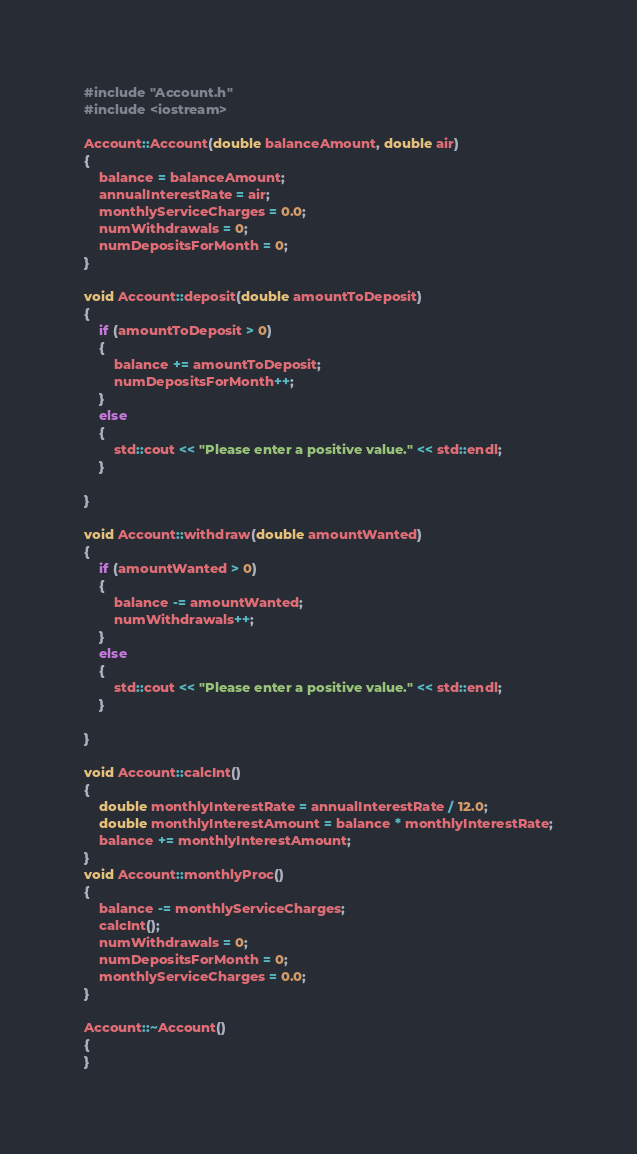<code> <loc_0><loc_0><loc_500><loc_500><_C++_>#include "Account.h"
#include <iostream>

Account::Account(double balanceAmount, double air)
{
	balance = balanceAmount;
	annualInterestRate = air;
	monthlyServiceCharges = 0.0;
	numWithdrawals = 0;
	numDepositsForMonth = 0;
}

void Account::deposit(double amountToDeposit) 
{
	if (amountToDeposit > 0)
	{
		balance += amountToDeposit;
		numDepositsForMonth++;
	}
	else
	{
		std::cout << "Please enter a positive value." << std::endl;
	}

}

void Account::withdraw(double amountWanted) 
{
	if (amountWanted > 0) 
	{
		balance -= amountWanted;
		numWithdrawals++;
	}
	else 
	{
		std::cout << "Please enter a positive value." << std::endl;
	}

}

void Account::calcInt() 
{
	double monthlyInterestRate = annualInterestRate / 12.0;
	double monthlyInterestAmount = balance * monthlyInterestRate;
	balance += monthlyInterestAmount;
}
void Account::monthlyProc() 
{
	balance -= monthlyServiceCharges;
	calcInt();
	numWithdrawals = 0;
	numDepositsForMonth = 0;
	monthlyServiceCharges = 0.0;
}

Account::~Account()
{
}
</code> 